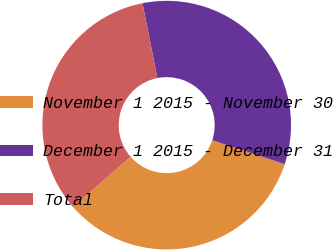<chart> <loc_0><loc_0><loc_500><loc_500><pie_chart><fcel>November 1 2015 - November 30<fcel>December 1 2015 - December 31<fcel>Total<nl><fcel>33.49%<fcel>33.2%<fcel>33.31%<nl></chart> 